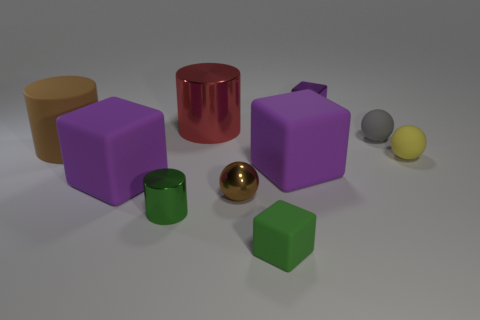There is a brown object that is to the left of the green metal object; what shape is it?
Offer a very short reply. Cylinder. The large metallic object is what color?
Your answer should be very brief. Red. There is a gray matte object; is its size the same as the brown thing that is right of the large rubber cylinder?
Make the answer very short. Yes. How many matte objects are big blue cylinders or small objects?
Your response must be concise. 3. Is there any other thing that has the same material as the green cube?
Your response must be concise. Yes. There is a metal block; does it have the same color as the ball that is behind the big rubber cylinder?
Offer a terse response. No. There is a gray thing; what shape is it?
Offer a very short reply. Sphere. There is a object on the left side of the big purple rubber cube to the left of the small ball that is on the left side of the green matte object; how big is it?
Give a very brief answer. Large. How many other objects are there of the same shape as the gray matte thing?
Provide a succinct answer. 2. There is a small green metal object that is in front of the small metallic ball; is its shape the same as the small thing in front of the green metal thing?
Make the answer very short. No. 